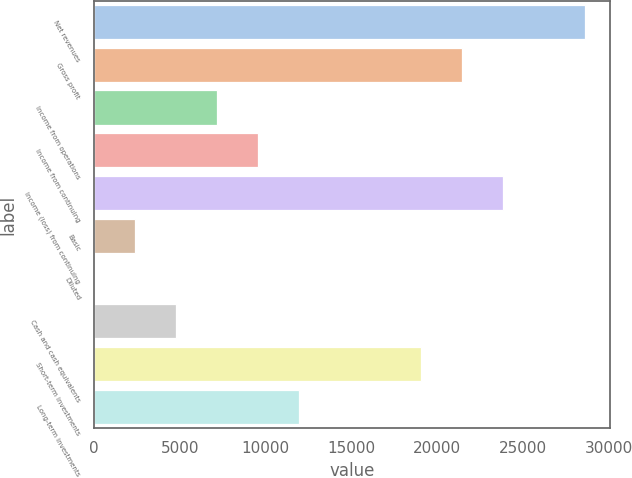Convert chart. <chart><loc_0><loc_0><loc_500><loc_500><bar_chart><fcel>Net revenues<fcel>Gross profit<fcel>Income from operations<fcel>Income from continuing<fcel>Income (loss) from continuing<fcel>Basic<fcel>Diluted<fcel>Cash and cash equivalents<fcel>Short-term investments<fcel>Long-term investments<nl><fcel>28615.1<fcel>21462.9<fcel>7158.55<fcel>9542.61<fcel>23847<fcel>2390.43<fcel>6.37<fcel>4774.49<fcel>19078.8<fcel>11926.7<nl></chart> 